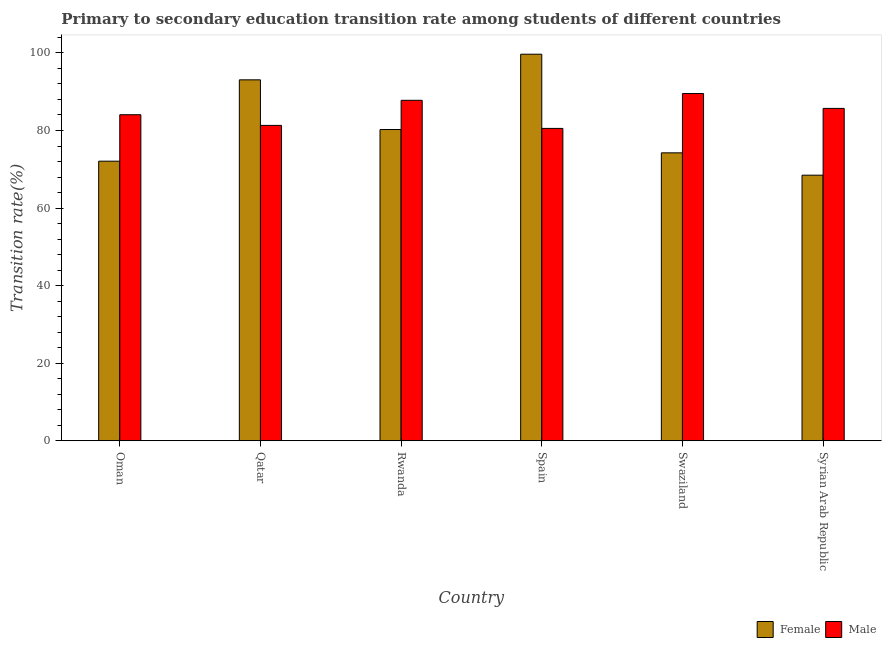How many different coloured bars are there?
Keep it short and to the point. 2. How many groups of bars are there?
Offer a very short reply. 6. How many bars are there on the 1st tick from the left?
Offer a terse response. 2. What is the label of the 2nd group of bars from the left?
Keep it short and to the point. Qatar. What is the transition rate among female students in Rwanda?
Provide a short and direct response. 80.25. Across all countries, what is the maximum transition rate among female students?
Your answer should be very brief. 99.67. Across all countries, what is the minimum transition rate among female students?
Give a very brief answer. 68.48. In which country was the transition rate among female students minimum?
Offer a terse response. Syrian Arab Republic. What is the total transition rate among female students in the graph?
Provide a succinct answer. 487.8. What is the difference between the transition rate among female students in Oman and that in Rwanda?
Keep it short and to the point. -8.16. What is the difference between the transition rate among female students in Qatar and the transition rate among male students in Rwanda?
Offer a terse response. 5.28. What is the average transition rate among male students per country?
Your response must be concise. 84.82. What is the difference between the transition rate among male students and transition rate among female students in Qatar?
Keep it short and to the point. -11.75. In how many countries, is the transition rate among female students greater than 56 %?
Your answer should be compact. 6. What is the ratio of the transition rate among female students in Spain to that in Swaziland?
Offer a terse response. 1.34. What is the difference between the highest and the second highest transition rate among female students?
Your answer should be very brief. 6.61. What is the difference between the highest and the lowest transition rate among female students?
Your response must be concise. 31.19. In how many countries, is the transition rate among female students greater than the average transition rate among female students taken over all countries?
Provide a short and direct response. 2. Is the sum of the transition rate among female students in Oman and Rwanda greater than the maximum transition rate among male students across all countries?
Make the answer very short. Yes. What does the 1st bar from the left in Spain represents?
Offer a very short reply. Female. How many countries are there in the graph?
Make the answer very short. 6. What is the difference between two consecutive major ticks on the Y-axis?
Provide a succinct answer. 20. Where does the legend appear in the graph?
Keep it short and to the point. Bottom right. How many legend labels are there?
Make the answer very short. 2. How are the legend labels stacked?
Make the answer very short. Horizontal. What is the title of the graph?
Offer a terse response. Primary to secondary education transition rate among students of different countries. Does "Domestic Liabilities" appear as one of the legend labels in the graph?
Keep it short and to the point. No. What is the label or title of the Y-axis?
Make the answer very short. Transition rate(%). What is the Transition rate(%) in Female in Oman?
Your response must be concise. 72.09. What is the Transition rate(%) in Male in Oman?
Offer a terse response. 84.07. What is the Transition rate(%) of Female in Qatar?
Offer a terse response. 93.06. What is the Transition rate(%) in Male in Qatar?
Offer a very short reply. 81.31. What is the Transition rate(%) of Female in Rwanda?
Make the answer very short. 80.25. What is the Transition rate(%) in Male in Rwanda?
Your response must be concise. 87.78. What is the Transition rate(%) in Female in Spain?
Keep it short and to the point. 99.67. What is the Transition rate(%) of Male in Spain?
Give a very brief answer. 80.54. What is the Transition rate(%) of Female in Swaziland?
Your answer should be compact. 74.24. What is the Transition rate(%) of Male in Swaziland?
Ensure brevity in your answer.  89.53. What is the Transition rate(%) in Female in Syrian Arab Republic?
Your answer should be compact. 68.48. What is the Transition rate(%) of Male in Syrian Arab Republic?
Give a very brief answer. 85.7. Across all countries, what is the maximum Transition rate(%) in Female?
Ensure brevity in your answer.  99.67. Across all countries, what is the maximum Transition rate(%) in Male?
Your answer should be very brief. 89.53. Across all countries, what is the minimum Transition rate(%) of Female?
Your answer should be very brief. 68.48. Across all countries, what is the minimum Transition rate(%) in Male?
Provide a succinct answer. 80.54. What is the total Transition rate(%) of Female in the graph?
Your answer should be compact. 487.8. What is the total Transition rate(%) in Male in the graph?
Your answer should be compact. 508.93. What is the difference between the Transition rate(%) in Female in Oman and that in Qatar?
Provide a succinct answer. -20.97. What is the difference between the Transition rate(%) of Male in Oman and that in Qatar?
Your response must be concise. 2.75. What is the difference between the Transition rate(%) of Female in Oman and that in Rwanda?
Offer a terse response. -8.16. What is the difference between the Transition rate(%) in Male in Oman and that in Rwanda?
Your answer should be very brief. -3.72. What is the difference between the Transition rate(%) of Female in Oman and that in Spain?
Ensure brevity in your answer.  -27.58. What is the difference between the Transition rate(%) of Male in Oman and that in Spain?
Ensure brevity in your answer.  3.53. What is the difference between the Transition rate(%) of Female in Oman and that in Swaziland?
Give a very brief answer. -2.15. What is the difference between the Transition rate(%) of Male in Oman and that in Swaziland?
Ensure brevity in your answer.  -5.46. What is the difference between the Transition rate(%) in Female in Oman and that in Syrian Arab Republic?
Provide a short and direct response. 3.61. What is the difference between the Transition rate(%) in Male in Oman and that in Syrian Arab Republic?
Give a very brief answer. -1.63. What is the difference between the Transition rate(%) of Female in Qatar and that in Rwanda?
Give a very brief answer. 12.81. What is the difference between the Transition rate(%) in Male in Qatar and that in Rwanda?
Ensure brevity in your answer.  -6.47. What is the difference between the Transition rate(%) of Female in Qatar and that in Spain?
Offer a terse response. -6.61. What is the difference between the Transition rate(%) of Male in Qatar and that in Spain?
Provide a short and direct response. 0.78. What is the difference between the Transition rate(%) in Female in Qatar and that in Swaziland?
Your answer should be compact. 18.82. What is the difference between the Transition rate(%) of Male in Qatar and that in Swaziland?
Your response must be concise. -8.21. What is the difference between the Transition rate(%) of Female in Qatar and that in Syrian Arab Republic?
Your response must be concise. 24.59. What is the difference between the Transition rate(%) of Male in Qatar and that in Syrian Arab Republic?
Provide a short and direct response. -4.38. What is the difference between the Transition rate(%) of Female in Rwanda and that in Spain?
Provide a succinct answer. -19.42. What is the difference between the Transition rate(%) of Male in Rwanda and that in Spain?
Give a very brief answer. 7.25. What is the difference between the Transition rate(%) in Female in Rwanda and that in Swaziland?
Your answer should be very brief. 6.01. What is the difference between the Transition rate(%) in Male in Rwanda and that in Swaziland?
Provide a short and direct response. -1.75. What is the difference between the Transition rate(%) of Female in Rwanda and that in Syrian Arab Republic?
Offer a very short reply. 11.77. What is the difference between the Transition rate(%) in Male in Rwanda and that in Syrian Arab Republic?
Provide a short and direct response. 2.09. What is the difference between the Transition rate(%) of Female in Spain and that in Swaziland?
Offer a terse response. 25.43. What is the difference between the Transition rate(%) of Male in Spain and that in Swaziland?
Offer a very short reply. -8.99. What is the difference between the Transition rate(%) of Female in Spain and that in Syrian Arab Republic?
Keep it short and to the point. 31.19. What is the difference between the Transition rate(%) of Male in Spain and that in Syrian Arab Republic?
Keep it short and to the point. -5.16. What is the difference between the Transition rate(%) in Female in Swaziland and that in Syrian Arab Republic?
Give a very brief answer. 5.76. What is the difference between the Transition rate(%) in Male in Swaziland and that in Syrian Arab Republic?
Offer a very short reply. 3.83. What is the difference between the Transition rate(%) in Female in Oman and the Transition rate(%) in Male in Qatar?
Provide a succinct answer. -9.22. What is the difference between the Transition rate(%) in Female in Oman and the Transition rate(%) in Male in Rwanda?
Provide a short and direct response. -15.69. What is the difference between the Transition rate(%) in Female in Oman and the Transition rate(%) in Male in Spain?
Your answer should be compact. -8.45. What is the difference between the Transition rate(%) in Female in Oman and the Transition rate(%) in Male in Swaziland?
Give a very brief answer. -17.44. What is the difference between the Transition rate(%) in Female in Oman and the Transition rate(%) in Male in Syrian Arab Republic?
Your answer should be very brief. -13.61. What is the difference between the Transition rate(%) of Female in Qatar and the Transition rate(%) of Male in Rwanda?
Keep it short and to the point. 5.28. What is the difference between the Transition rate(%) of Female in Qatar and the Transition rate(%) of Male in Spain?
Your answer should be compact. 12.53. What is the difference between the Transition rate(%) in Female in Qatar and the Transition rate(%) in Male in Swaziland?
Keep it short and to the point. 3.53. What is the difference between the Transition rate(%) in Female in Qatar and the Transition rate(%) in Male in Syrian Arab Republic?
Give a very brief answer. 7.37. What is the difference between the Transition rate(%) of Female in Rwanda and the Transition rate(%) of Male in Spain?
Make the answer very short. -0.29. What is the difference between the Transition rate(%) in Female in Rwanda and the Transition rate(%) in Male in Swaziland?
Your answer should be very brief. -9.28. What is the difference between the Transition rate(%) of Female in Rwanda and the Transition rate(%) of Male in Syrian Arab Republic?
Your response must be concise. -5.45. What is the difference between the Transition rate(%) of Female in Spain and the Transition rate(%) of Male in Swaziland?
Give a very brief answer. 10.14. What is the difference between the Transition rate(%) in Female in Spain and the Transition rate(%) in Male in Syrian Arab Republic?
Provide a succinct answer. 13.97. What is the difference between the Transition rate(%) in Female in Swaziland and the Transition rate(%) in Male in Syrian Arab Republic?
Provide a short and direct response. -11.46. What is the average Transition rate(%) in Female per country?
Provide a succinct answer. 81.3. What is the average Transition rate(%) of Male per country?
Your answer should be very brief. 84.82. What is the difference between the Transition rate(%) of Female and Transition rate(%) of Male in Oman?
Make the answer very short. -11.98. What is the difference between the Transition rate(%) of Female and Transition rate(%) of Male in Qatar?
Offer a very short reply. 11.75. What is the difference between the Transition rate(%) in Female and Transition rate(%) in Male in Rwanda?
Ensure brevity in your answer.  -7.53. What is the difference between the Transition rate(%) of Female and Transition rate(%) of Male in Spain?
Make the answer very short. 19.13. What is the difference between the Transition rate(%) in Female and Transition rate(%) in Male in Swaziland?
Ensure brevity in your answer.  -15.29. What is the difference between the Transition rate(%) in Female and Transition rate(%) in Male in Syrian Arab Republic?
Make the answer very short. -17.22. What is the ratio of the Transition rate(%) of Female in Oman to that in Qatar?
Keep it short and to the point. 0.77. What is the ratio of the Transition rate(%) in Male in Oman to that in Qatar?
Your answer should be compact. 1.03. What is the ratio of the Transition rate(%) of Female in Oman to that in Rwanda?
Give a very brief answer. 0.9. What is the ratio of the Transition rate(%) in Male in Oman to that in Rwanda?
Ensure brevity in your answer.  0.96. What is the ratio of the Transition rate(%) of Female in Oman to that in Spain?
Keep it short and to the point. 0.72. What is the ratio of the Transition rate(%) of Male in Oman to that in Spain?
Your response must be concise. 1.04. What is the ratio of the Transition rate(%) in Female in Oman to that in Swaziland?
Your answer should be very brief. 0.97. What is the ratio of the Transition rate(%) in Male in Oman to that in Swaziland?
Offer a terse response. 0.94. What is the ratio of the Transition rate(%) of Female in Oman to that in Syrian Arab Republic?
Provide a short and direct response. 1.05. What is the ratio of the Transition rate(%) of Female in Qatar to that in Rwanda?
Keep it short and to the point. 1.16. What is the ratio of the Transition rate(%) of Male in Qatar to that in Rwanda?
Make the answer very short. 0.93. What is the ratio of the Transition rate(%) of Female in Qatar to that in Spain?
Make the answer very short. 0.93. What is the ratio of the Transition rate(%) of Male in Qatar to that in Spain?
Your response must be concise. 1.01. What is the ratio of the Transition rate(%) of Female in Qatar to that in Swaziland?
Give a very brief answer. 1.25. What is the ratio of the Transition rate(%) of Male in Qatar to that in Swaziland?
Offer a very short reply. 0.91. What is the ratio of the Transition rate(%) in Female in Qatar to that in Syrian Arab Republic?
Offer a very short reply. 1.36. What is the ratio of the Transition rate(%) of Male in Qatar to that in Syrian Arab Republic?
Offer a very short reply. 0.95. What is the ratio of the Transition rate(%) of Female in Rwanda to that in Spain?
Provide a short and direct response. 0.81. What is the ratio of the Transition rate(%) of Male in Rwanda to that in Spain?
Provide a succinct answer. 1.09. What is the ratio of the Transition rate(%) of Female in Rwanda to that in Swaziland?
Offer a very short reply. 1.08. What is the ratio of the Transition rate(%) of Male in Rwanda to that in Swaziland?
Your answer should be very brief. 0.98. What is the ratio of the Transition rate(%) in Female in Rwanda to that in Syrian Arab Republic?
Keep it short and to the point. 1.17. What is the ratio of the Transition rate(%) in Male in Rwanda to that in Syrian Arab Republic?
Offer a terse response. 1.02. What is the ratio of the Transition rate(%) in Female in Spain to that in Swaziland?
Offer a terse response. 1.34. What is the ratio of the Transition rate(%) of Male in Spain to that in Swaziland?
Provide a succinct answer. 0.9. What is the ratio of the Transition rate(%) of Female in Spain to that in Syrian Arab Republic?
Your response must be concise. 1.46. What is the ratio of the Transition rate(%) in Male in Spain to that in Syrian Arab Republic?
Your response must be concise. 0.94. What is the ratio of the Transition rate(%) of Female in Swaziland to that in Syrian Arab Republic?
Provide a short and direct response. 1.08. What is the ratio of the Transition rate(%) of Male in Swaziland to that in Syrian Arab Republic?
Offer a terse response. 1.04. What is the difference between the highest and the second highest Transition rate(%) of Female?
Keep it short and to the point. 6.61. What is the difference between the highest and the second highest Transition rate(%) of Male?
Your answer should be very brief. 1.75. What is the difference between the highest and the lowest Transition rate(%) of Female?
Provide a succinct answer. 31.19. What is the difference between the highest and the lowest Transition rate(%) in Male?
Keep it short and to the point. 8.99. 